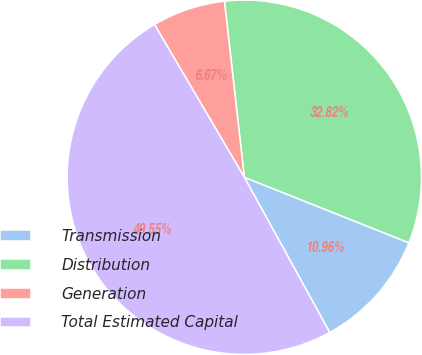Convert chart to OTSL. <chart><loc_0><loc_0><loc_500><loc_500><pie_chart><fcel>Transmission<fcel>Distribution<fcel>Generation<fcel>Total Estimated Capital<nl><fcel>10.96%<fcel>32.82%<fcel>6.67%<fcel>49.55%<nl></chart> 